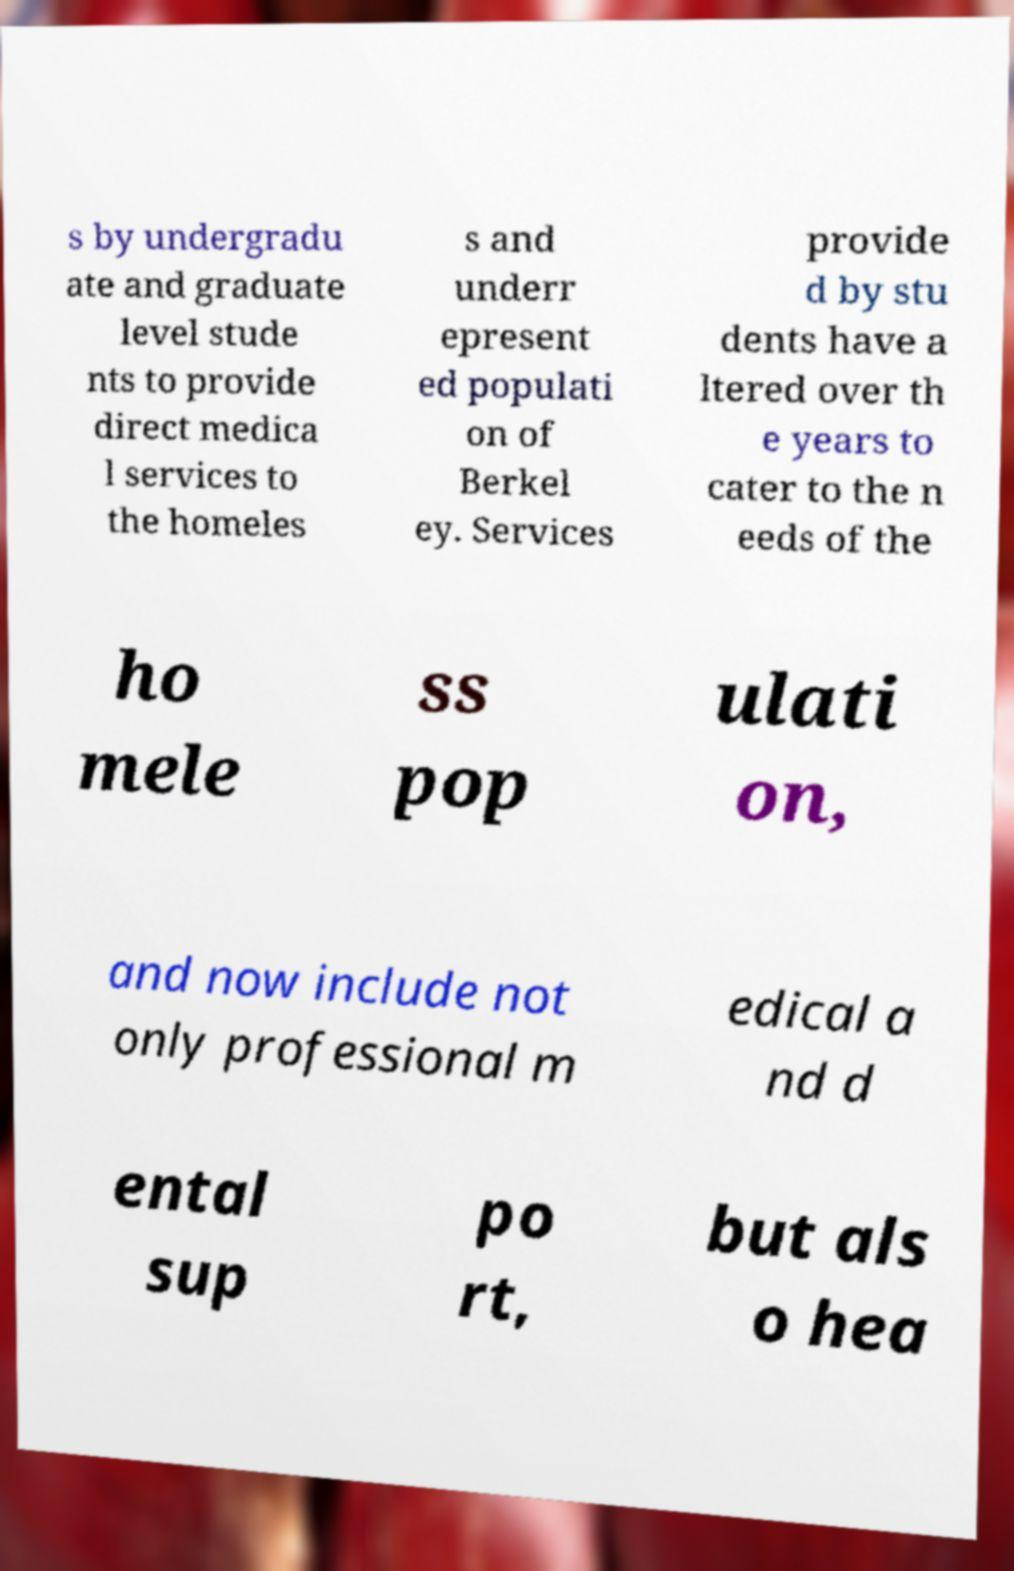For documentation purposes, I need the text within this image transcribed. Could you provide that? s by undergradu ate and graduate level stude nts to provide direct medica l services to the homeles s and underr epresent ed populati on of Berkel ey. Services provide d by stu dents have a ltered over th e years to cater to the n eeds of the ho mele ss pop ulati on, and now include not only professional m edical a nd d ental sup po rt, but als o hea 